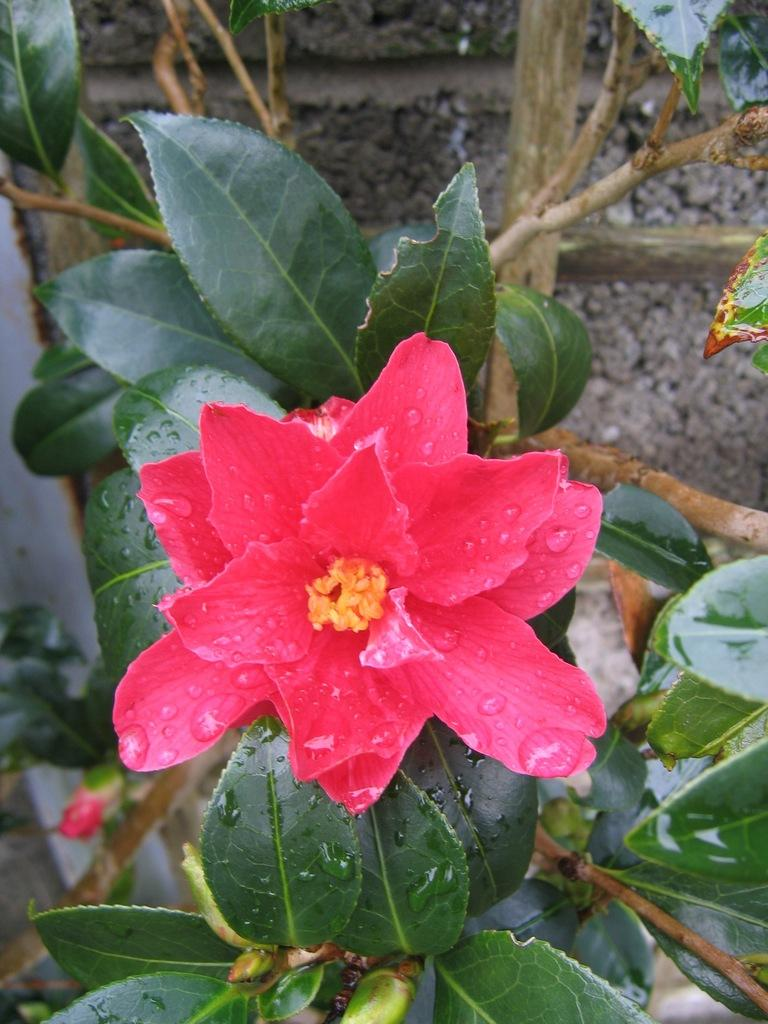What type of plant is visible in the image? There is a plant with a flower in the image. What can be seen in the background of the image? There is a wall in the background of the image. What type of cushion is being used to divide the plant from the cable in the image? There is no cushion, division, or cable present in the image. 